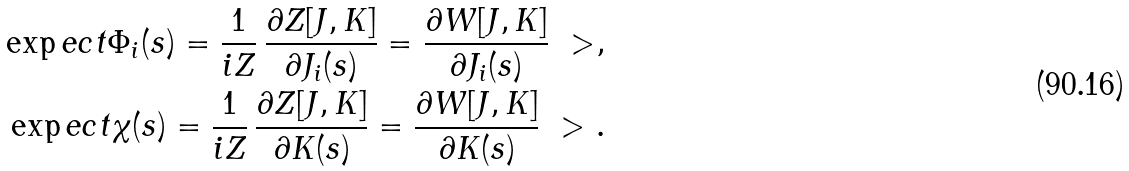Convert formula to latex. <formula><loc_0><loc_0><loc_500><loc_500>\exp e c t { \Phi _ { i } ( s ) } = \frac { 1 } { i Z } \, \frac { \partial Z [ J , K ] } { \partial J _ { i } ( s ) } = \frac { \partial W [ J , K ] } { \partial J _ { i } ( s ) } \ > , \\ \exp e c t { \chi ( s ) } = \frac { 1 } { i Z } \, \frac { \partial Z [ J , K ] } { \partial K ( s ) } = \frac { \partial W [ J , K ] } { \partial K ( s ) } \ > .</formula> 